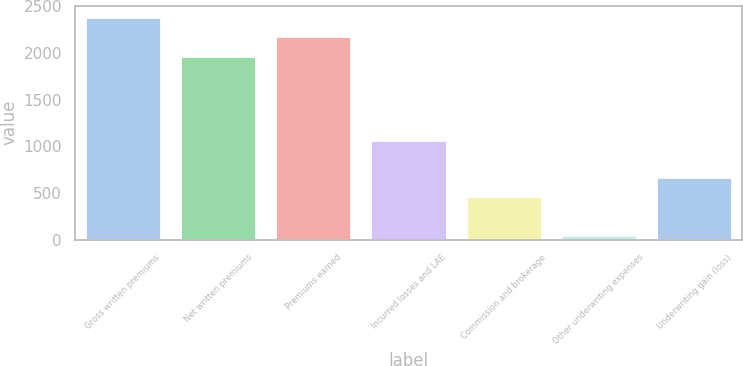Convert chart. <chart><loc_0><loc_0><loc_500><loc_500><bar_chart><fcel>Gross written premiums<fcel>Net written premiums<fcel>Premiums earned<fcel>Incurred losses and LAE<fcel>Commission and brokerage<fcel>Other underwriting expenses<fcel>Underwriting gain (loss)<nl><fcel>2384.94<fcel>1970.6<fcel>2177.77<fcel>1068.5<fcel>466<fcel>54.1<fcel>673.17<nl></chart> 